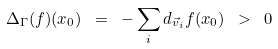Convert formula to latex. <formula><loc_0><loc_0><loc_500><loc_500>\Delta _ { \Gamma } ( f ) ( x _ { 0 } ) \ = \ - \sum _ { i } d _ { \vec { v } _ { i } } f ( x _ { 0 } ) \ > \ 0</formula> 